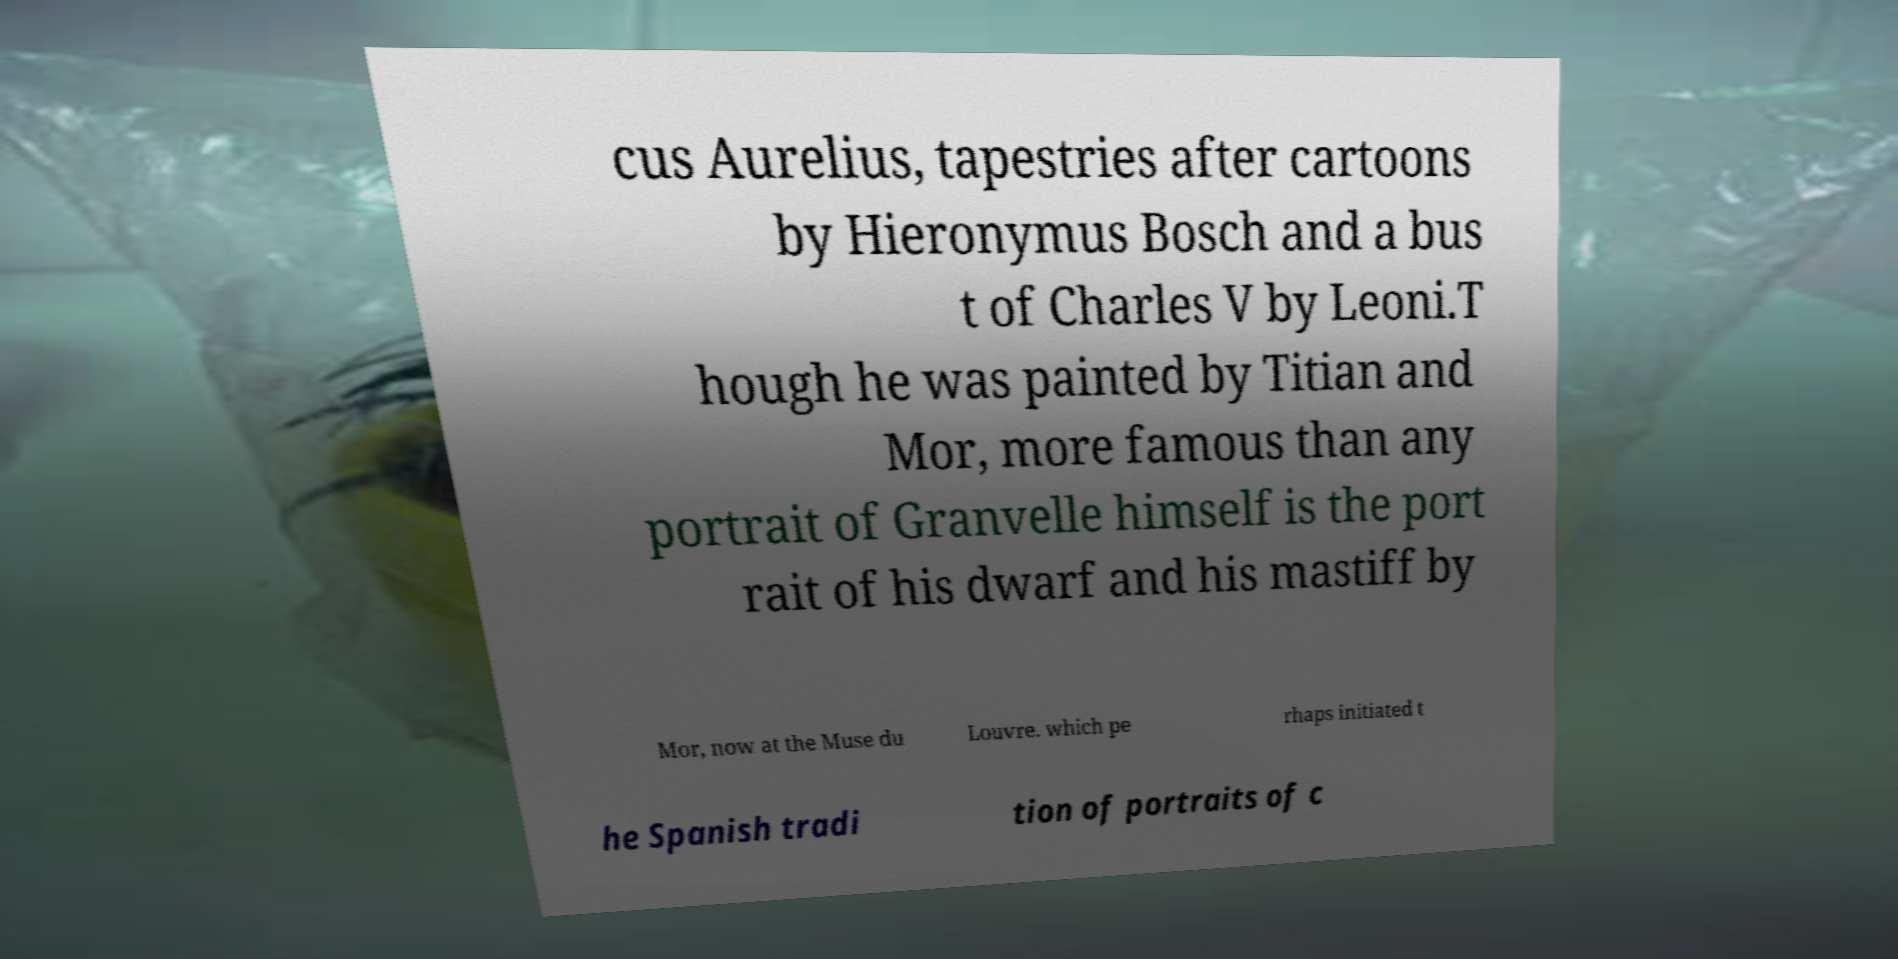What messages or text are displayed in this image? I need them in a readable, typed format. cus Aurelius, tapestries after cartoons by Hieronymus Bosch and a bus t of Charles V by Leoni.T hough he was painted by Titian and Mor, more famous than any portrait of Granvelle himself is the port rait of his dwarf and his mastiff by Mor, now at the Muse du Louvre. which pe rhaps initiated t he Spanish tradi tion of portraits of c 